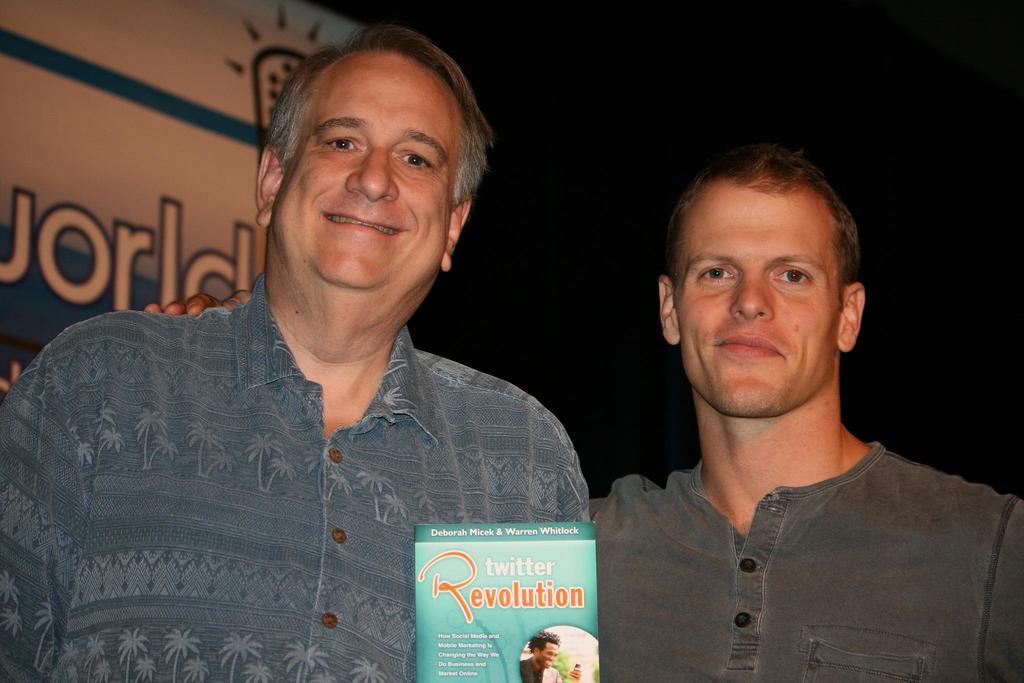Could you give a brief overview of what you see in this image? There are two men. In front of them there is a packet. On the packet there is something written. Also there is an image on the packet. In the background it is dark. Also there is a wall with something written on that. 